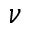<formula> <loc_0><loc_0><loc_500><loc_500>\nu</formula> 